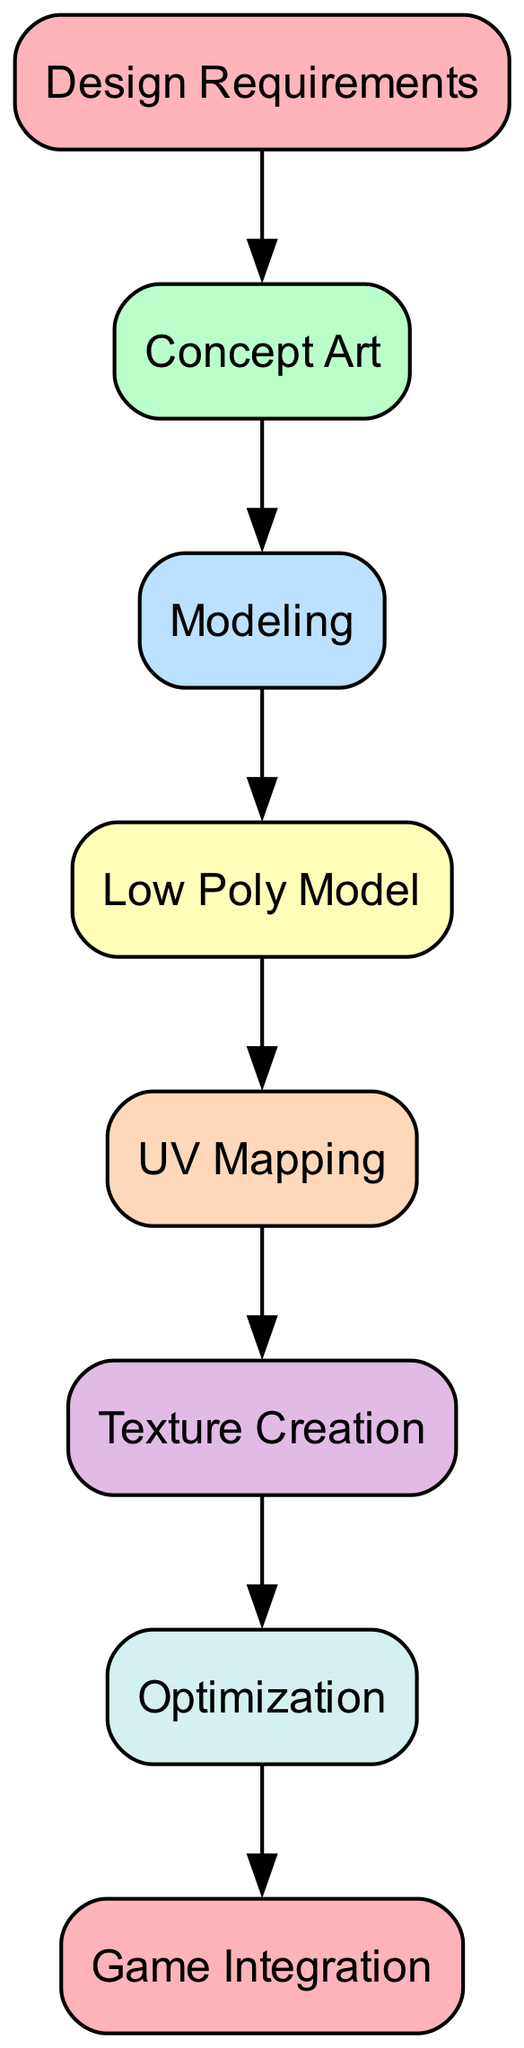What's the first step in the process of creating a 3D prop? The first node in the diagram is "Design Requirements," indicating that this is where the process begins.
Answer: Design Requirements How many nodes are present in the diagram? By counting each of the unique nodes listed in the diagram, we find there are a total of 8 nodes.
Answer: 8 What connects "UV Mapping" and "Texture Creation"? The directed edge from "UV Mapping" to "Texture Creation" indicates a direct relationship where UV Mapping precedes Texture Creation in the workflow.
Answer: An edge What is the last step before "Game Integration"? Looking at the diagram, "Optimization" is the node that directly precedes "Game Integration," indicating it is the final step before integrating the game.
Answer: Optimization What step follows the creation of the Low Poly Model? The diagram shows that after "Low Poly Model," the next step is "UV Mapping," establishing a clear connection in the workflow.
Answer: UV Mapping At which stage is concept art produced? The diagram illustrates that "Concept Art" is produced immediately following "Design Requirements," exemplifying the order of tasks in the process.
Answer: After Design Requirements Which step involves creating textures? The node labeled "Texture Creation" specifically addresses the step of creating textures in the overall process, making it the answer to this inquiry.
Answer: Texture Creation How do "Modeling" and "UV Mapping" relate to each other? The diagram shows a directed relationship, where "Modeling" leads directly to "Low Poly Model," which in turn connects to "UV Mapping," indicating that modeling provides a foundation for UV mapping.
Answer: Directed relationship 